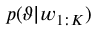Convert formula to latex. <formula><loc_0><loc_0><loc_500><loc_500>p ( \vartheta | w _ { 1 \colon K } )</formula> 